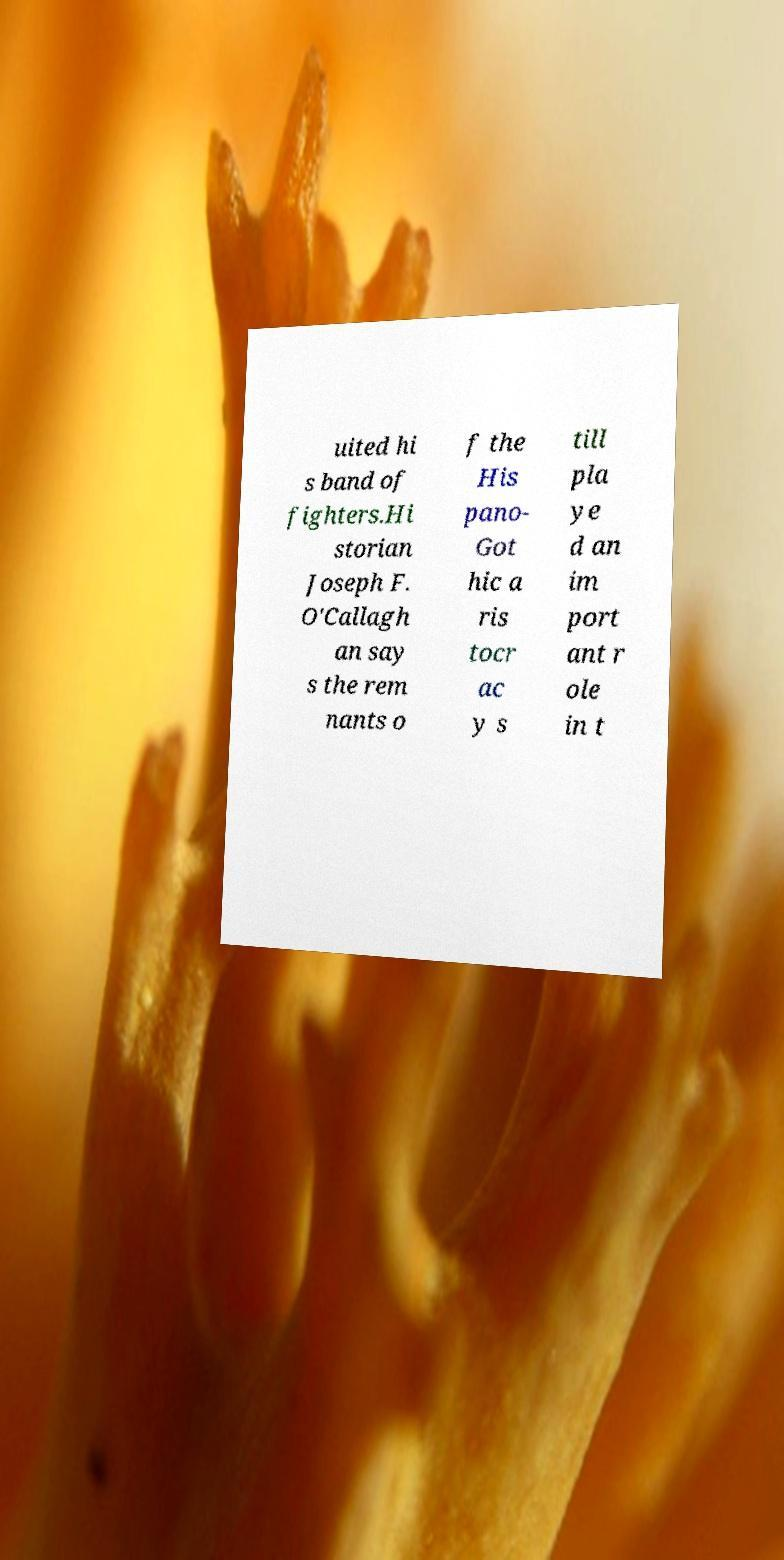Can you read and provide the text displayed in the image?This photo seems to have some interesting text. Can you extract and type it out for me? uited hi s band of fighters.Hi storian Joseph F. O'Callagh an say s the rem nants o f the His pano- Got hic a ris tocr ac y s till pla ye d an im port ant r ole in t 